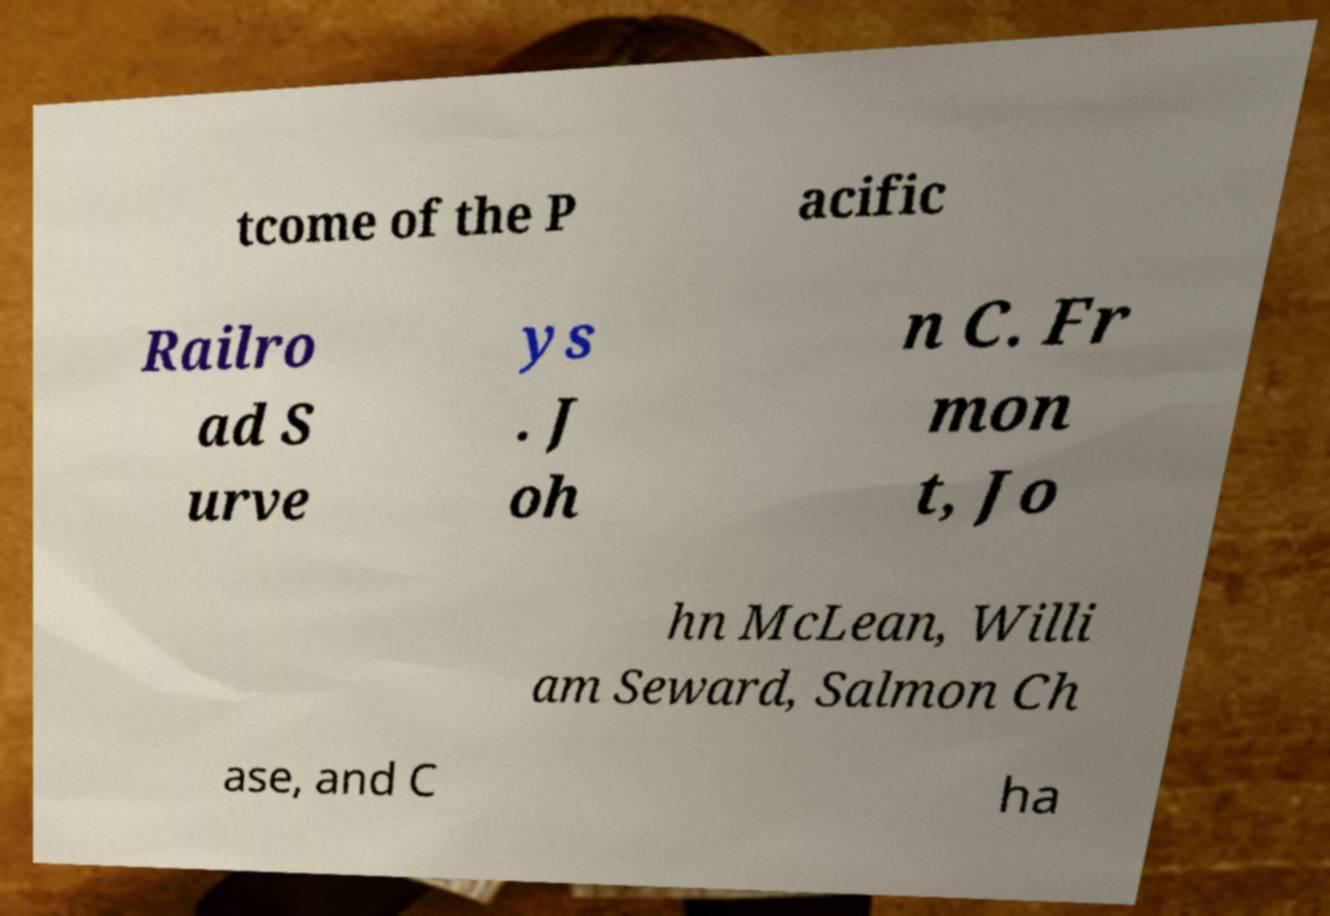Please read and relay the text visible in this image. What does it say? tcome of the P acific Railro ad S urve ys . J oh n C. Fr mon t, Jo hn McLean, Willi am Seward, Salmon Ch ase, and C ha 